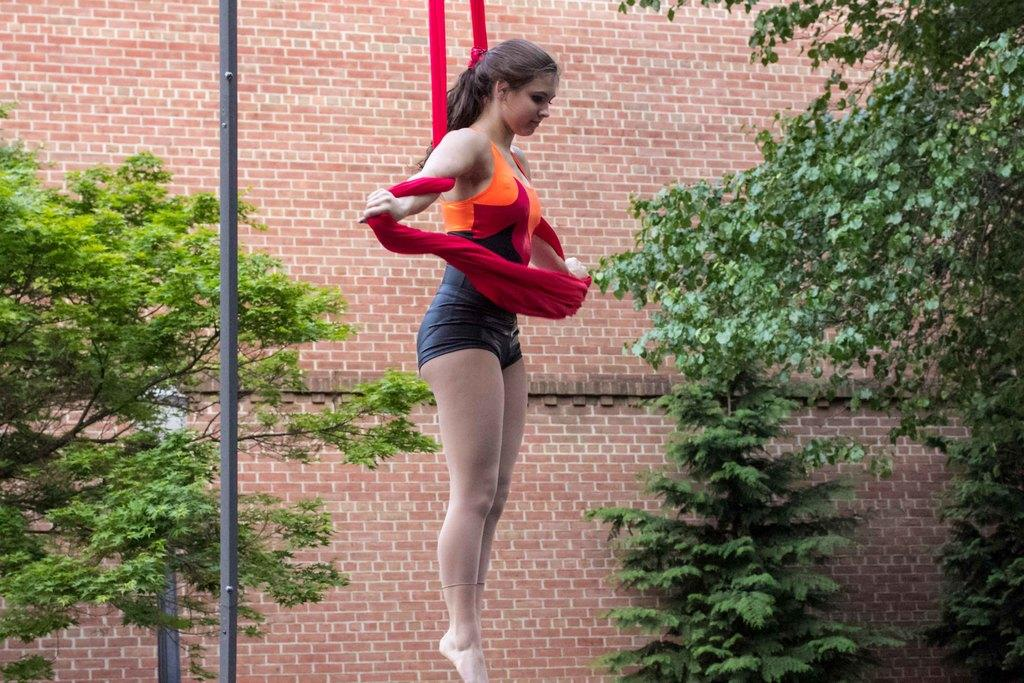What is the woman in the image doing? The woman is standing in the image and holding a cloth. What can be seen on the left side of the image? There is a pole on the left side of the image. What is visible in the background of the image? Trees and a building are visible in the background of the image. What type of stove can be seen in the image? There is no stove present in the image. Is the woman cooking anything on the stove in the image? There is no stove or cooking activity depicted in the image. 